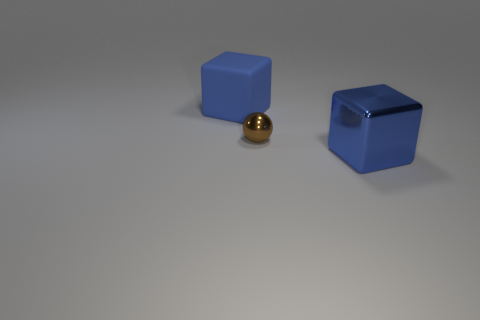What number of things are to the right of the metal sphere and behind the large shiny block?
Give a very brief answer. 0. Is there any other thing that is the same size as the brown metallic thing?
Your answer should be very brief. No. Are there more blue shiny things that are in front of the metallic cube than brown shiny spheres that are on the right side of the tiny metallic object?
Keep it short and to the point. No. There is a block that is to the right of the brown metallic ball; what is it made of?
Provide a succinct answer. Metal. There is a blue rubber object; is it the same shape as the thing right of the small brown metallic sphere?
Provide a short and direct response. Yes. There is a blue cube to the left of the large blue cube on the right side of the brown metallic thing; how many big blue blocks are on the left side of it?
Ensure brevity in your answer.  0. The other big object that is the same shape as the blue metallic object is what color?
Provide a succinct answer. Blue. Are there any other things that have the same shape as the tiny thing?
Your answer should be compact. No. How many cylinders are small brown metal objects or big metallic things?
Offer a terse response. 0. The big matte thing is what shape?
Ensure brevity in your answer.  Cube. 